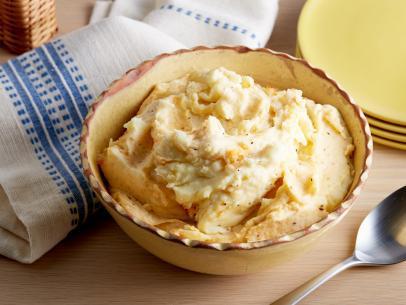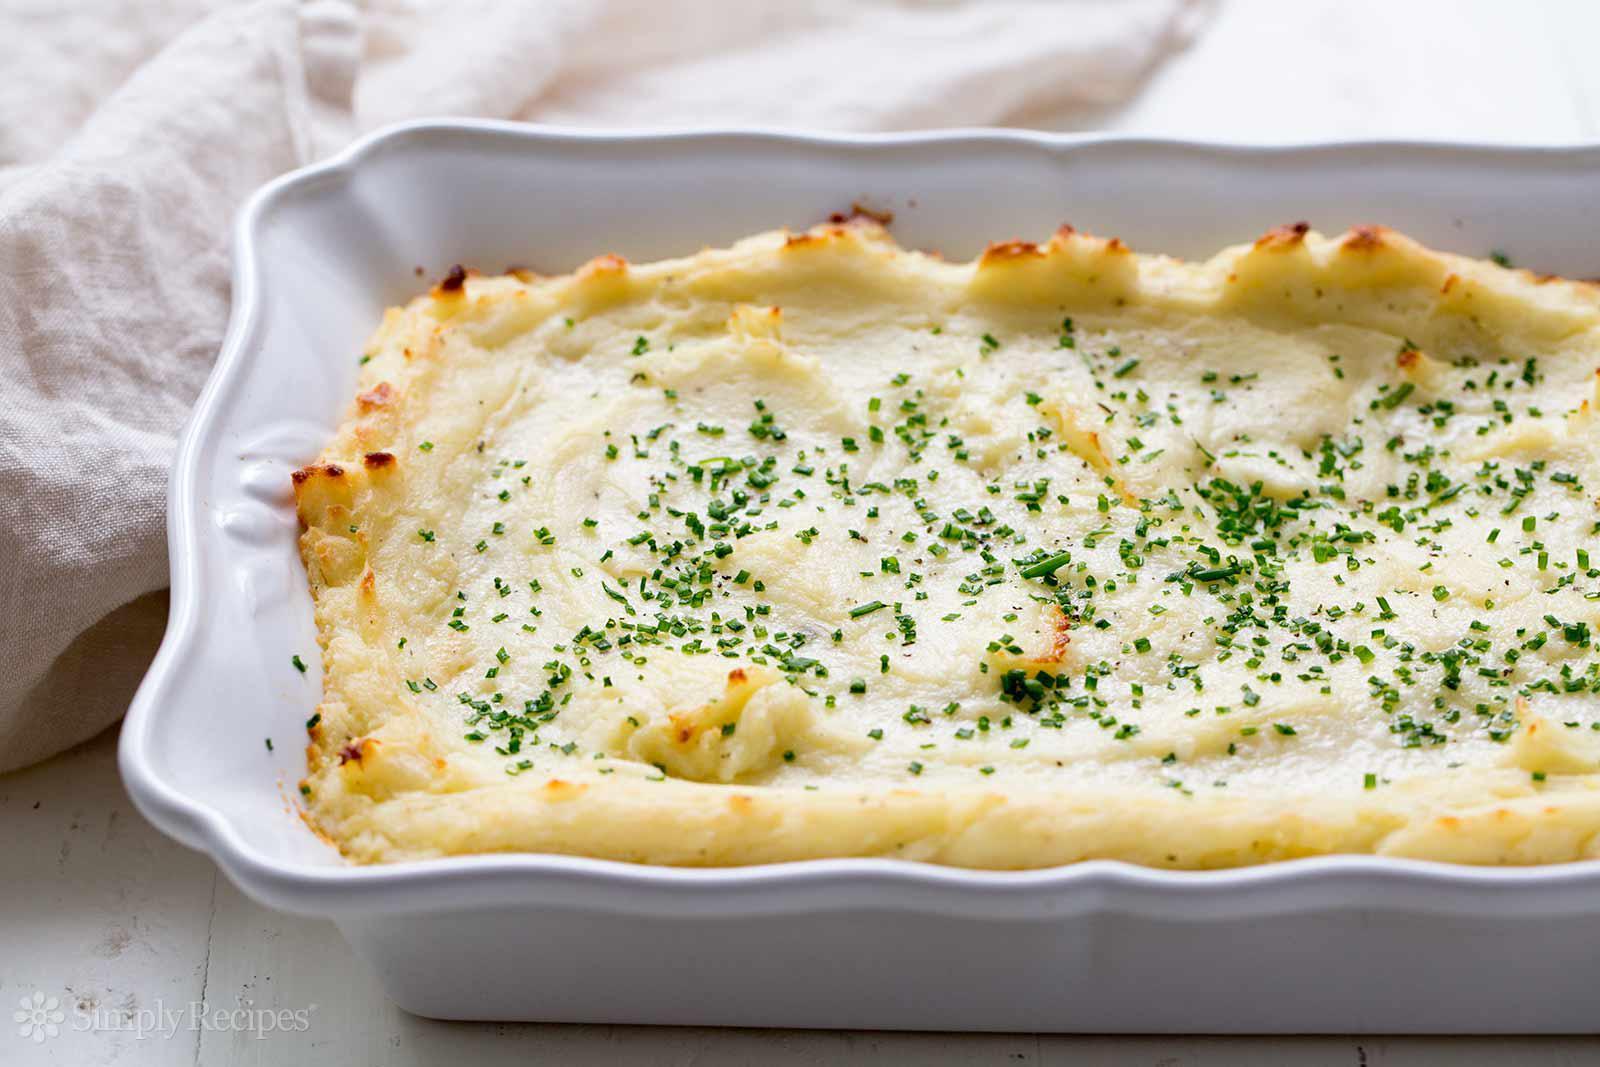The first image is the image on the left, the second image is the image on the right. For the images shown, is this caption "the casserole dish on the image in the right side is rectangular and white." true? Answer yes or no. Yes. The first image is the image on the left, the second image is the image on the right. For the images shown, is this caption "A casserole is in a white rectangular baking dish with chopped green chives on top." true? Answer yes or no. Yes. 